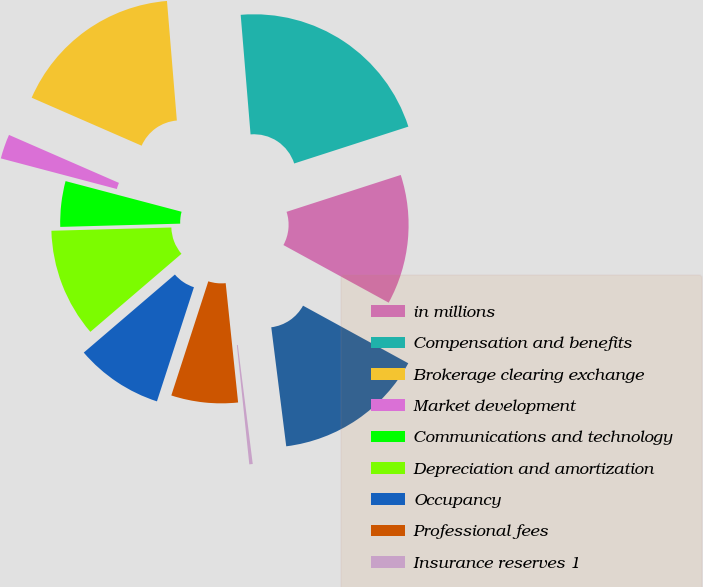Convert chart to OTSL. <chart><loc_0><loc_0><loc_500><loc_500><pie_chart><fcel>in millions<fcel>Compensation and benefits<fcel>Brokerage clearing exchange<fcel>Market development<fcel>Communications and technology<fcel>Depreciation and amortization<fcel>Occupancy<fcel>Professional fees<fcel>Insurance reserves 1<fcel>Other expenses<nl><fcel>12.94%<fcel>21.34%<fcel>17.14%<fcel>2.44%<fcel>4.54%<fcel>10.84%<fcel>8.74%<fcel>6.64%<fcel>0.34%<fcel>15.04%<nl></chart> 